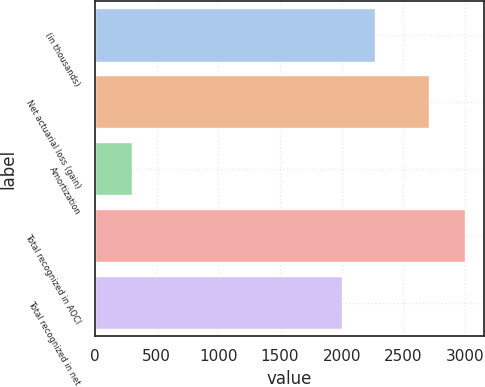Convert chart to OTSL. <chart><loc_0><loc_0><loc_500><loc_500><bar_chart><fcel>(in thousands)<fcel>Net actuarial loss (gain)<fcel>Amortization<fcel>Total recognized in AOCI<fcel>Total recognized in net<nl><fcel>2269.8<fcel>2709<fcel>305<fcel>3003<fcel>2000<nl></chart> 